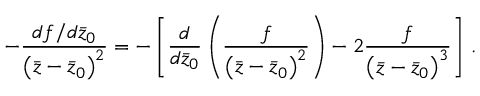<formula> <loc_0><loc_0><loc_500><loc_500>- \frac { d f / d \bar { z } _ { 0 } } { \left ( \bar { z } - \bar { z } _ { 0 } \right ) ^ { 2 } } = - \left [ \frac { d } { d \bar { z } _ { 0 } } \left ( \frac { f } { \left ( \bar { z } - \bar { z } _ { 0 } \right ) ^ { 2 } } \right ) - 2 \frac { f } { \left ( \bar { z } - \bar { z } _ { 0 } \right ) ^ { 3 } } \right ] \, .</formula> 